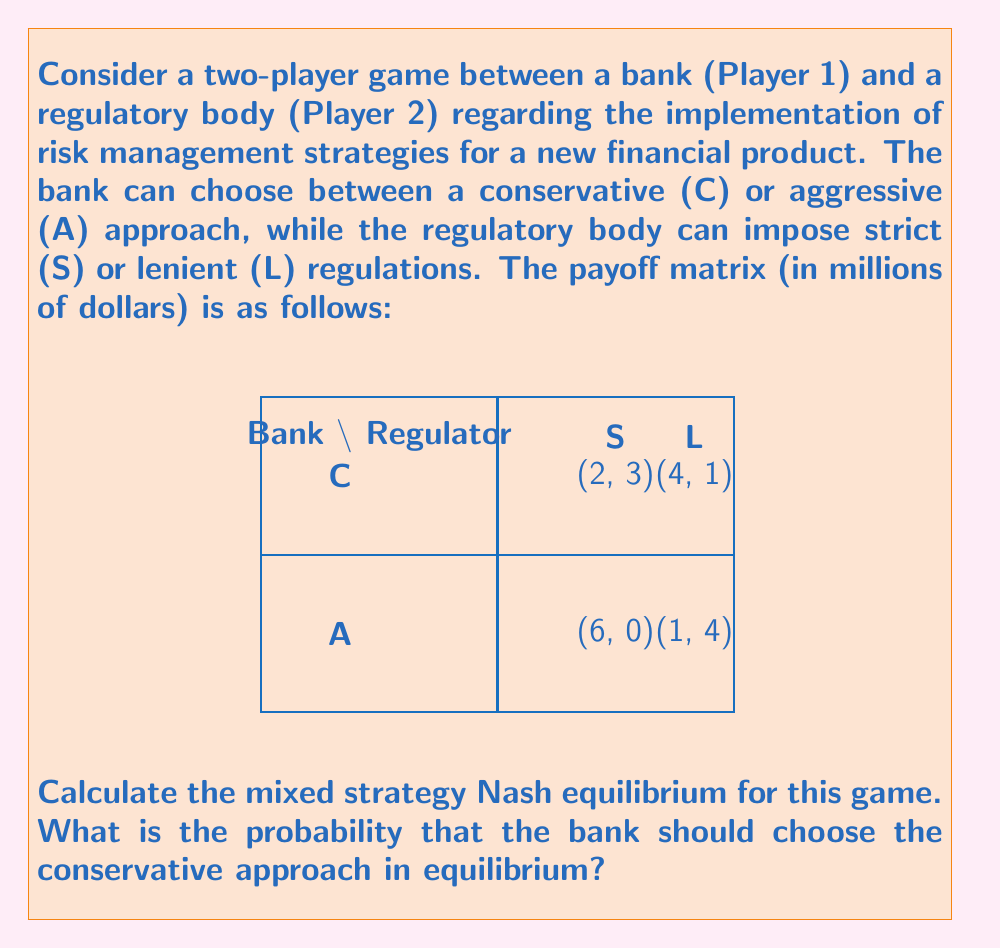Could you help me with this problem? To find the mixed strategy Nash equilibrium, we need to make each player indifferent between their strategies:

1) Let $p$ be the probability that the bank chooses C, and $q$ be the probability that the regulator chooses S.

2) For the regulator to be indifferent:
   $3p + 0(1-p) = 1p + 4(1-p)$
   $3p = 1p + 4 - 4p$
   $6p = 4$
   $p = \frac{2}{3}$

3) For the bank to be indifferent:
   $2q + 4(1-q) = 6q + 1(1-q)$
   $2q + 4 - 4q = 6q + 1 - q$
   $4 - 2q = 5q + 1$
   $3 = 7q$
   $q = \frac{3}{7}$

4) The mixed strategy Nash equilibrium is $(\frac{2}{3}C + \frac{1}{3}A, \frac{3}{7}S + \frac{4}{7}L)$

5) The probability that the bank should choose the conservative approach in equilibrium is $\frac{2}{3}$.
Answer: $\frac{2}{3}$ 